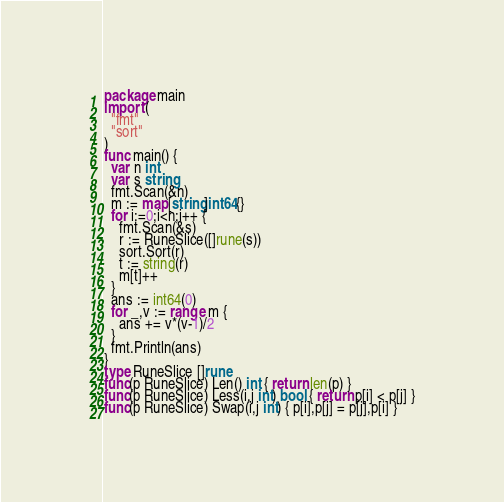Convert code to text. <code><loc_0><loc_0><loc_500><loc_500><_Go_>package main
import (
  "fmt"
  "sort"
)
func main() {
  var n int
  var s string
  fmt.Scan(&n)
  m := map[string]int64{}
  for i:=0;i<n;i++ {
    fmt.Scan(&s)
    r := RuneSlice([]rune(s))
    sort.Sort(r)
    t := string(r)
    m[t]++
  }
  ans := int64(0)
  for _,v := range m {
    ans += v*(v-1)/2
  }
  fmt.Println(ans)
}
type RuneSlice []rune
func(p RuneSlice) Len() int { return len(p) }
func(p RuneSlice) Less(i,j int) bool { return p[i] < p[j] }
func(p RuneSlice) Swap(i,j int) { p[i],p[j] = p[j],p[i] }</code> 